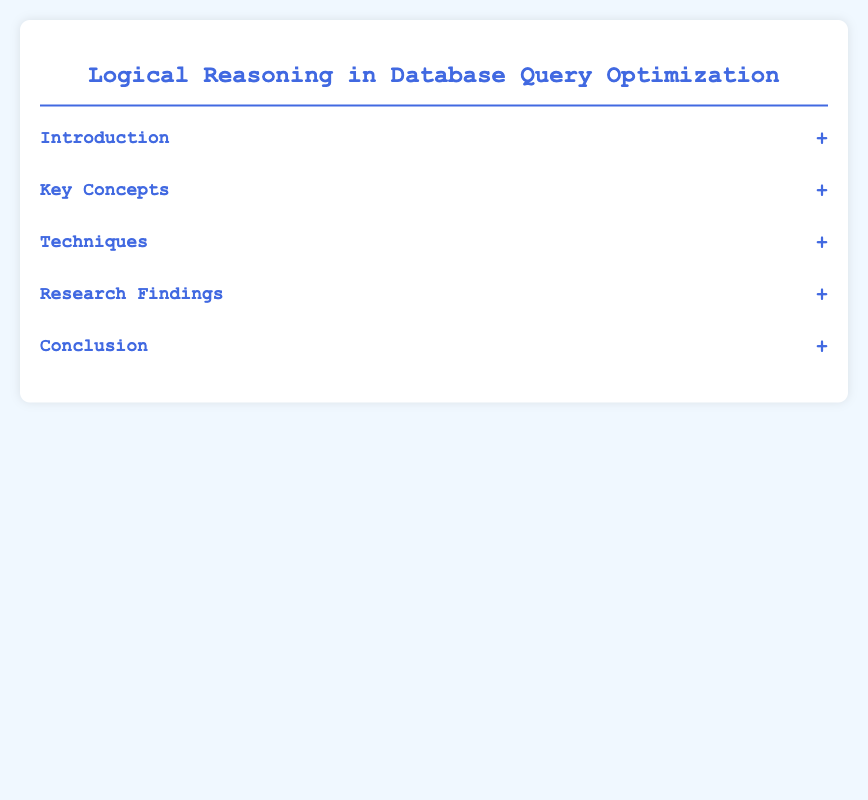What is the title of the presentation? The title of the presentation is provided in the document header.
Answer: Logical Reasoning in Database Query Optimization What is the significance of logical query plans? Logical query plans are defined as an abstraction for query optimization.
Answer: Abstraction for query optimization What technique involves reducing data processed by filtering early? This technique aims to enhance query execution efficiency through early filtering.
Answer: Predicate Pushdown What are the two main subjects of the research findings? The research findings section contains specific insight topics described in the document.
Answer: Comparative Studies, AI and Query Optimization How many techniques are listed in the document? The techniques section contains a specific number of entries described in the content.
Answer: Three What key concept enhances query optimization beyond syntactic transformations? This concept refers to enhancing query performance through a broader understanding of the context.
Answer: Semantic Query Optimization Which technique involves logical properties for join order? This technique emphasizes the importance of ordering in query processing based on logical characteristics.
Answer: Join Ordering What is the last section of the document? The document is structured into several sections, and the last one summarizes the previous findings.
Answer: Conclusion 